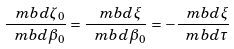Convert formula to latex. <formula><loc_0><loc_0><loc_500><loc_500>\frac { \ m b { d } \zeta _ { 0 } } { \ m b { d } \beta _ { 0 } } = \frac { \ m b { d } \xi } { \ m b { d } \beta _ { 0 } } = - \frac { \ m b { d } \xi } { \ m b { d } \tau }</formula> 